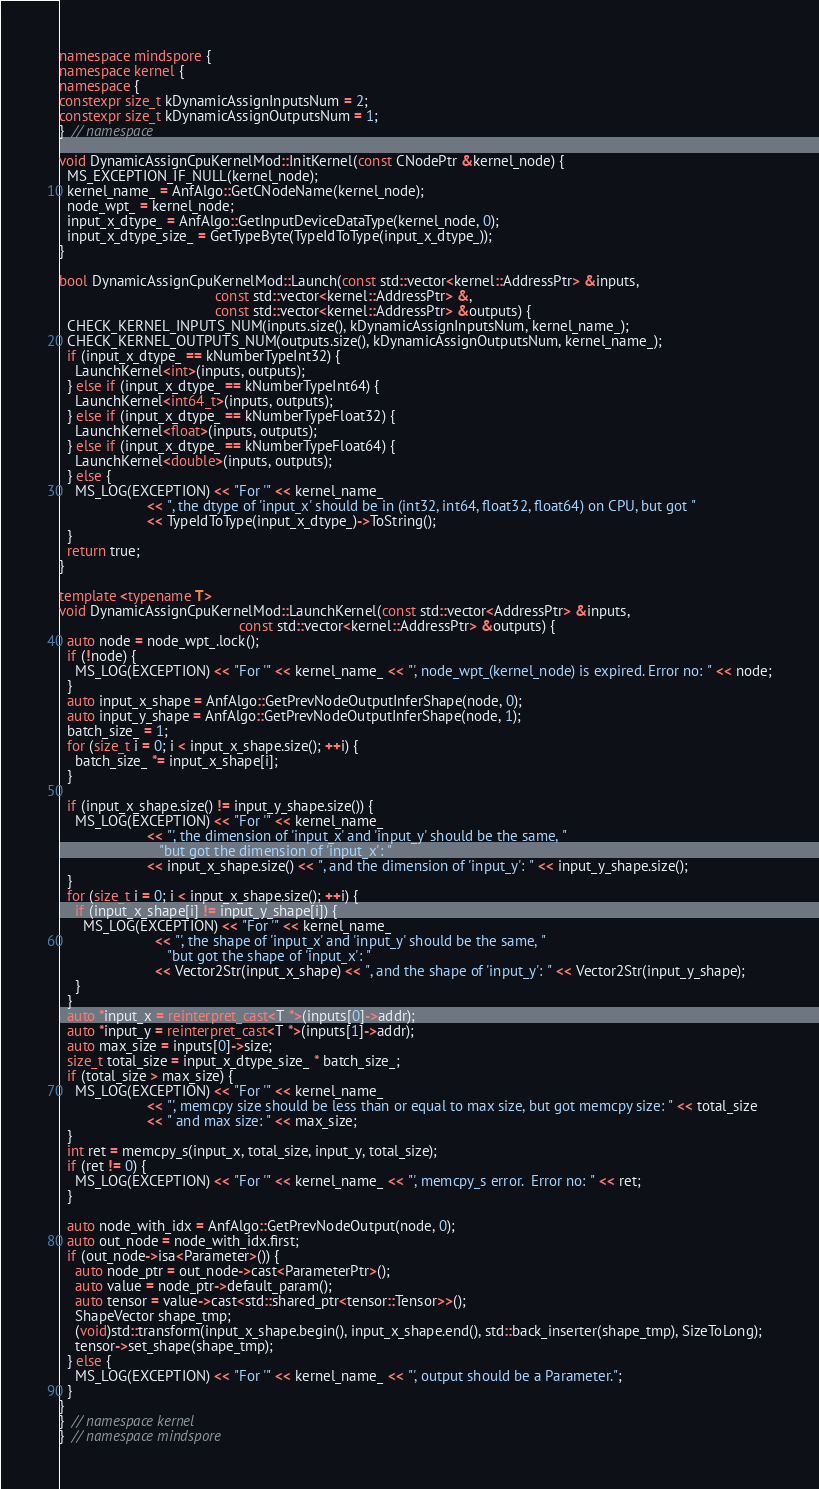Convert code to text. <code><loc_0><loc_0><loc_500><loc_500><_C++_>namespace mindspore {
namespace kernel {
namespace {
constexpr size_t kDynamicAssignInputsNum = 2;
constexpr size_t kDynamicAssignOutputsNum = 1;
}  // namespace

void DynamicAssignCpuKernelMod::InitKernel(const CNodePtr &kernel_node) {
  MS_EXCEPTION_IF_NULL(kernel_node);
  kernel_name_ = AnfAlgo::GetCNodeName(kernel_node);
  node_wpt_ = kernel_node;
  input_x_dtype_ = AnfAlgo::GetInputDeviceDataType(kernel_node, 0);
  input_x_dtype_size_ = GetTypeByte(TypeIdToType(input_x_dtype_));
}

bool DynamicAssignCpuKernelMod::Launch(const std::vector<kernel::AddressPtr> &inputs,
                                       const std::vector<kernel::AddressPtr> &,
                                       const std::vector<kernel::AddressPtr> &outputs) {
  CHECK_KERNEL_INPUTS_NUM(inputs.size(), kDynamicAssignInputsNum, kernel_name_);
  CHECK_KERNEL_OUTPUTS_NUM(outputs.size(), kDynamicAssignOutputsNum, kernel_name_);
  if (input_x_dtype_ == kNumberTypeInt32) {
    LaunchKernel<int>(inputs, outputs);
  } else if (input_x_dtype_ == kNumberTypeInt64) {
    LaunchKernel<int64_t>(inputs, outputs);
  } else if (input_x_dtype_ == kNumberTypeFloat32) {
    LaunchKernel<float>(inputs, outputs);
  } else if (input_x_dtype_ == kNumberTypeFloat64) {
    LaunchKernel<double>(inputs, outputs);
  } else {
    MS_LOG(EXCEPTION) << "For '" << kernel_name_
                      << ", the dtype of 'input_x' should be in (int32, int64, float32, float64) on CPU, but got "
                      << TypeIdToType(input_x_dtype_)->ToString();
  }
  return true;
}

template <typename T>
void DynamicAssignCpuKernelMod::LaunchKernel(const std::vector<AddressPtr> &inputs,
                                             const std::vector<kernel::AddressPtr> &outputs) {
  auto node = node_wpt_.lock();
  if (!node) {
    MS_LOG(EXCEPTION) << "For '" << kernel_name_ << "', node_wpt_(kernel_node) is expired. Error no: " << node;
  }
  auto input_x_shape = AnfAlgo::GetPrevNodeOutputInferShape(node, 0);
  auto input_y_shape = AnfAlgo::GetPrevNodeOutputInferShape(node, 1);
  batch_size_ = 1;
  for (size_t i = 0; i < input_x_shape.size(); ++i) {
    batch_size_ *= input_x_shape[i];
  }

  if (input_x_shape.size() != input_y_shape.size()) {
    MS_LOG(EXCEPTION) << "For '" << kernel_name_
                      << "', the dimension of 'input_x' and 'input_y' should be the same, "
                         "but got the dimension of 'input_x': "
                      << input_x_shape.size() << ", and the dimension of 'input_y': " << input_y_shape.size();
  }
  for (size_t i = 0; i < input_x_shape.size(); ++i) {
    if (input_x_shape[i] != input_y_shape[i]) {
      MS_LOG(EXCEPTION) << "For '" << kernel_name_
                        << "', the shape of 'input_x' and 'input_y' should be the same, "
                           "but got the shape of 'input_x': "
                        << Vector2Str(input_x_shape) << ", and the shape of 'input_y': " << Vector2Str(input_y_shape);
    }
  }
  auto *input_x = reinterpret_cast<T *>(inputs[0]->addr);
  auto *input_y = reinterpret_cast<T *>(inputs[1]->addr);
  auto max_size = inputs[0]->size;
  size_t total_size = input_x_dtype_size_ * batch_size_;
  if (total_size > max_size) {
    MS_LOG(EXCEPTION) << "For '" << kernel_name_
                      << "', memcpy size should be less than or equal to max size, but got memcpy size: " << total_size
                      << " and max size: " << max_size;
  }
  int ret = memcpy_s(input_x, total_size, input_y, total_size);
  if (ret != 0) {
    MS_LOG(EXCEPTION) << "For '" << kernel_name_ << "', memcpy_s error.  Error no: " << ret;
  }

  auto node_with_idx = AnfAlgo::GetPrevNodeOutput(node, 0);
  auto out_node = node_with_idx.first;
  if (out_node->isa<Parameter>()) {
    auto node_ptr = out_node->cast<ParameterPtr>();
    auto value = node_ptr->default_param();
    auto tensor = value->cast<std::shared_ptr<tensor::Tensor>>();
    ShapeVector shape_tmp;
    (void)std::transform(input_x_shape.begin(), input_x_shape.end(), std::back_inserter(shape_tmp), SizeToLong);
    tensor->set_shape(shape_tmp);
  } else {
    MS_LOG(EXCEPTION) << "For '" << kernel_name_ << "', output should be a Parameter.";
  }
}
}  // namespace kernel
}  // namespace mindspore
</code> 